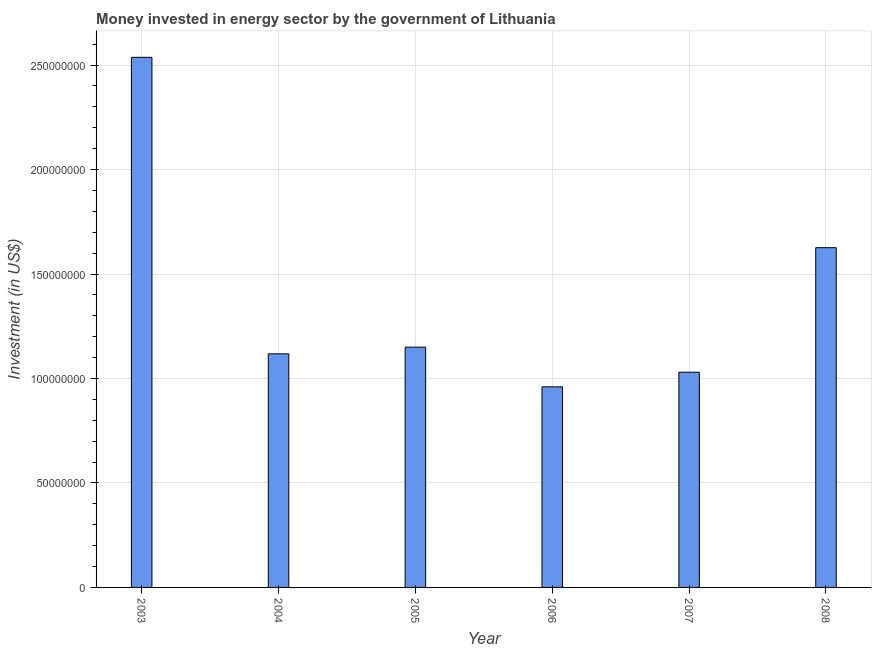Does the graph contain any zero values?
Provide a succinct answer. No. What is the title of the graph?
Your answer should be compact. Money invested in energy sector by the government of Lithuania. What is the label or title of the X-axis?
Provide a succinct answer. Year. What is the label or title of the Y-axis?
Ensure brevity in your answer.  Investment (in US$). What is the investment in energy in 2003?
Your answer should be compact. 2.54e+08. Across all years, what is the maximum investment in energy?
Provide a short and direct response. 2.54e+08. Across all years, what is the minimum investment in energy?
Offer a terse response. 9.60e+07. In which year was the investment in energy minimum?
Make the answer very short. 2006. What is the sum of the investment in energy?
Your answer should be very brief. 8.42e+08. What is the difference between the investment in energy in 2006 and 2008?
Provide a short and direct response. -6.66e+07. What is the average investment in energy per year?
Keep it short and to the point. 1.40e+08. What is the median investment in energy?
Offer a terse response. 1.13e+08. In how many years, is the investment in energy greater than 10000000 US$?
Give a very brief answer. 6. What is the ratio of the investment in energy in 2004 to that in 2005?
Give a very brief answer. 0.97. Is the difference between the investment in energy in 2003 and 2005 greater than the difference between any two years?
Your answer should be very brief. No. What is the difference between the highest and the second highest investment in energy?
Provide a short and direct response. 9.11e+07. What is the difference between the highest and the lowest investment in energy?
Ensure brevity in your answer.  1.58e+08. How many years are there in the graph?
Offer a very short reply. 6. Are the values on the major ticks of Y-axis written in scientific E-notation?
Provide a short and direct response. No. What is the Investment (in US$) of 2003?
Give a very brief answer. 2.54e+08. What is the Investment (in US$) in 2004?
Your response must be concise. 1.12e+08. What is the Investment (in US$) in 2005?
Offer a terse response. 1.15e+08. What is the Investment (in US$) of 2006?
Your response must be concise. 9.60e+07. What is the Investment (in US$) of 2007?
Offer a terse response. 1.03e+08. What is the Investment (in US$) in 2008?
Make the answer very short. 1.63e+08. What is the difference between the Investment (in US$) in 2003 and 2004?
Your answer should be very brief. 1.42e+08. What is the difference between the Investment (in US$) in 2003 and 2005?
Give a very brief answer. 1.39e+08. What is the difference between the Investment (in US$) in 2003 and 2006?
Your answer should be very brief. 1.58e+08. What is the difference between the Investment (in US$) in 2003 and 2007?
Provide a short and direct response. 1.51e+08. What is the difference between the Investment (in US$) in 2003 and 2008?
Provide a succinct answer. 9.11e+07. What is the difference between the Investment (in US$) in 2004 and 2005?
Give a very brief answer. -3.20e+06. What is the difference between the Investment (in US$) in 2004 and 2006?
Provide a short and direct response. 1.58e+07. What is the difference between the Investment (in US$) in 2004 and 2007?
Your answer should be very brief. 8.80e+06. What is the difference between the Investment (in US$) in 2004 and 2008?
Provide a succinct answer. -5.08e+07. What is the difference between the Investment (in US$) in 2005 and 2006?
Your answer should be very brief. 1.90e+07. What is the difference between the Investment (in US$) in 2005 and 2008?
Offer a very short reply. -4.76e+07. What is the difference between the Investment (in US$) in 2006 and 2007?
Your answer should be very brief. -7.00e+06. What is the difference between the Investment (in US$) in 2006 and 2008?
Offer a terse response. -6.66e+07. What is the difference between the Investment (in US$) in 2007 and 2008?
Your response must be concise. -5.96e+07. What is the ratio of the Investment (in US$) in 2003 to that in 2004?
Offer a very short reply. 2.27. What is the ratio of the Investment (in US$) in 2003 to that in 2005?
Your response must be concise. 2.21. What is the ratio of the Investment (in US$) in 2003 to that in 2006?
Offer a very short reply. 2.64. What is the ratio of the Investment (in US$) in 2003 to that in 2007?
Keep it short and to the point. 2.46. What is the ratio of the Investment (in US$) in 2003 to that in 2008?
Make the answer very short. 1.56. What is the ratio of the Investment (in US$) in 2004 to that in 2005?
Your answer should be very brief. 0.97. What is the ratio of the Investment (in US$) in 2004 to that in 2006?
Offer a very short reply. 1.17. What is the ratio of the Investment (in US$) in 2004 to that in 2007?
Give a very brief answer. 1.08. What is the ratio of the Investment (in US$) in 2004 to that in 2008?
Give a very brief answer. 0.69. What is the ratio of the Investment (in US$) in 2005 to that in 2006?
Make the answer very short. 1.2. What is the ratio of the Investment (in US$) in 2005 to that in 2007?
Provide a succinct answer. 1.12. What is the ratio of the Investment (in US$) in 2005 to that in 2008?
Provide a short and direct response. 0.71. What is the ratio of the Investment (in US$) in 2006 to that in 2007?
Offer a very short reply. 0.93. What is the ratio of the Investment (in US$) in 2006 to that in 2008?
Offer a terse response. 0.59. What is the ratio of the Investment (in US$) in 2007 to that in 2008?
Offer a very short reply. 0.63. 